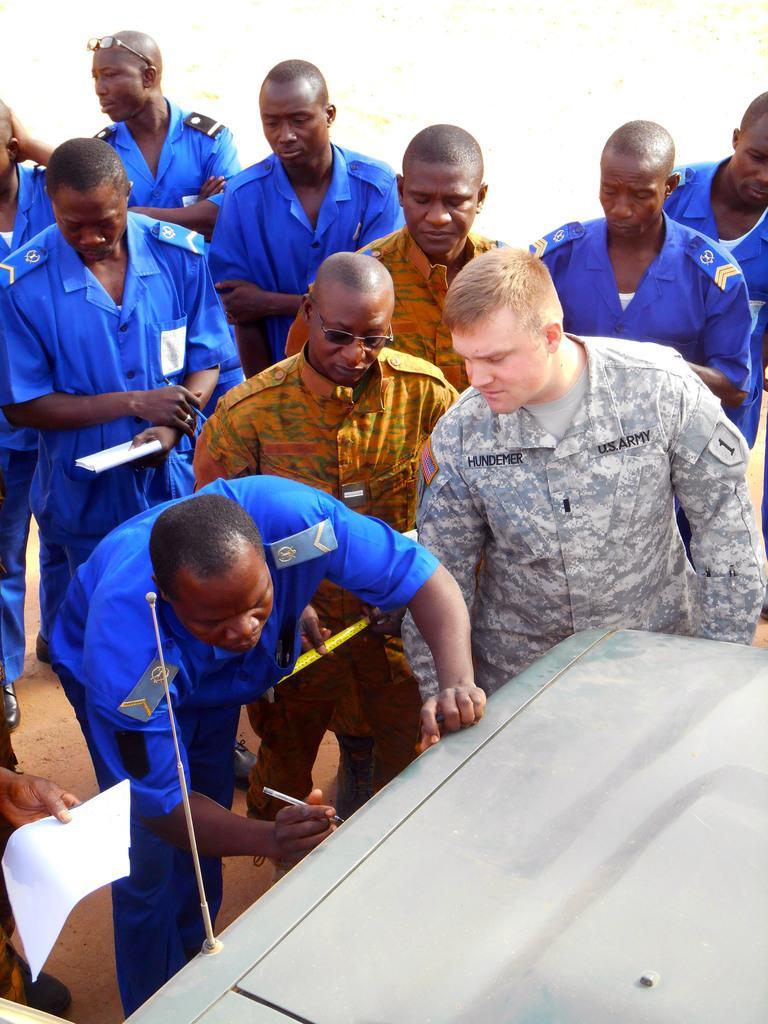Please provide a concise description of this image. This image is taken outdoors. In the middle of the image a few men are standing on the ground and a few are holding books and pens in their hands. A man is standing and holding a pen in his hand. He is writing with a pen on the vehicle. At the bottom of the image there is a vehicle. 